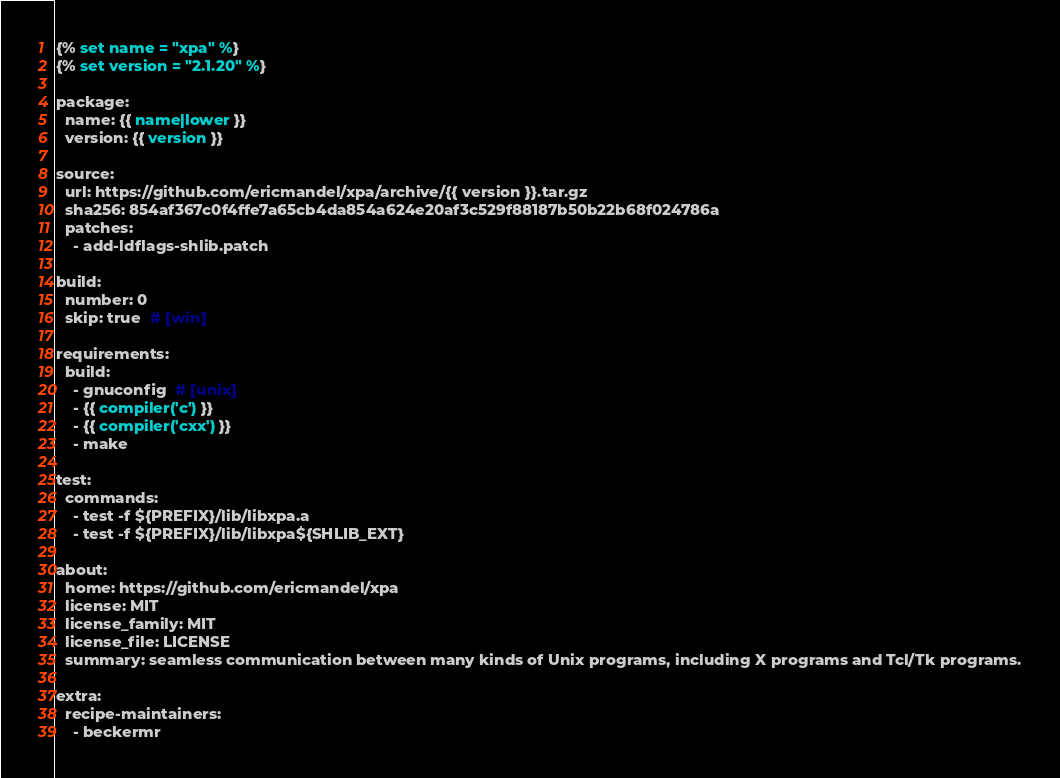Convert code to text. <code><loc_0><loc_0><loc_500><loc_500><_YAML_>{% set name = "xpa" %}
{% set version = "2.1.20" %}

package:
  name: {{ name|lower }}
  version: {{ version }}

source:
  url: https://github.com/ericmandel/xpa/archive/{{ version }}.tar.gz
  sha256: 854af367c0f4ffe7a65cb4da854a624e20af3c529f88187b50b22b68f024786a
  patches:
    - add-ldflags-shlib.patch

build:
  number: 0
  skip: true  # [win]

requirements:
  build:
    - gnuconfig  # [unix]
    - {{ compiler('c') }}
    - {{ compiler('cxx') }}
    - make

test:
  commands:
    - test -f ${PREFIX}/lib/libxpa.a
    - test -f ${PREFIX}/lib/libxpa${SHLIB_EXT}

about:
  home: https://github.com/ericmandel/xpa
  license: MIT
  license_family: MIT
  license_file: LICENSE
  summary: seamless communication between many kinds of Unix programs, including X programs and Tcl/Tk programs.

extra:
  recipe-maintainers:
    - beckermr
</code> 